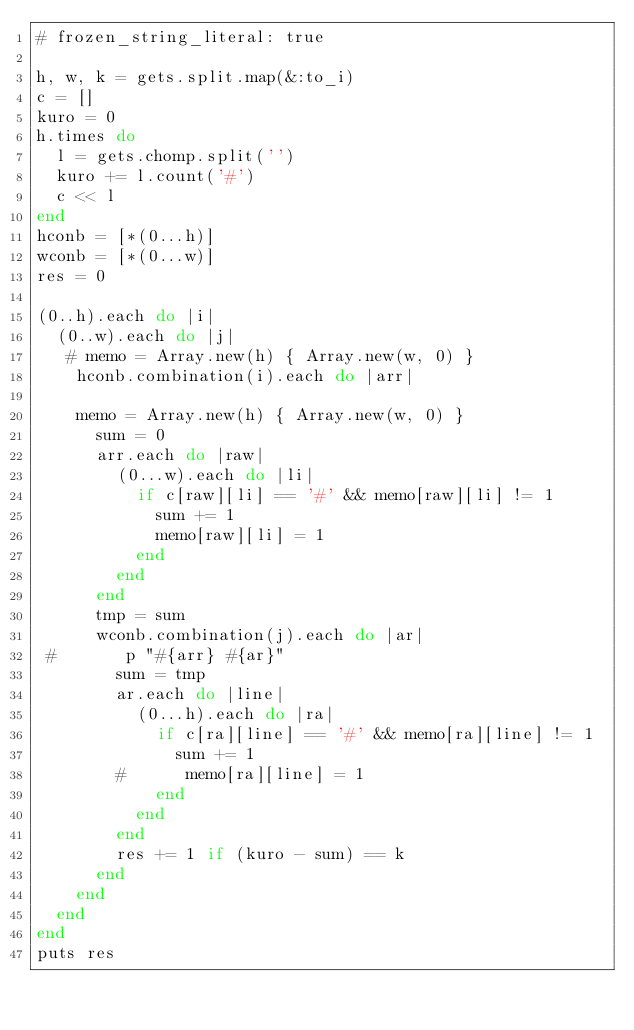Convert code to text. <code><loc_0><loc_0><loc_500><loc_500><_Ruby_># frozen_string_literal: true

h, w, k = gets.split.map(&:to_i)
c = []
kuro = 0
h.times do
  l = gets.chomp.split('')
  kuro += l.count('#')
  c << l
end
hconb = [*(0...h)]
wconb = [*(0...w)]
res = 0

(0..h).each do |i|
  (0..w).each do |j|
   # memo = Array.new(h) { Array.new(w, 0) }
    hconb.combination(i).each do |arr|

    memo = Array.new(h) { Array.new(w, 0) }
      sum = 0
      arr.each do |raw|
        (0...w).each do |li|
          if c[raw][li] == '#' && memo[raw][li] != 1
            sum += 1
            memo[raw][li] = 1
          end
        end
      end
      tmp = sum
      wconb.combination(j).each do |ar|
 #       p "#{arr} #{ar}"
        sum = tmp
        ar.each do |line|
          (0...h).each do |ra|
            if c[ra][line] == '#' && memo[ra][line] != 1
              sum += 1
        #      memo[ra][line] = 1
            end
          end
        end
        res += 1 if (kuro - sum) == k
      end
    end
  end
end
puts res
</code> 